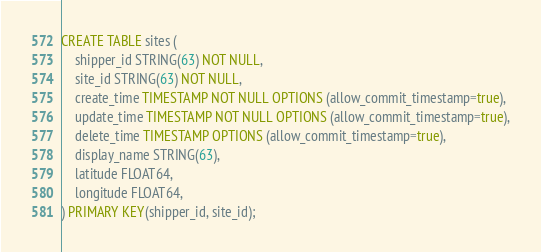Convert code to text. <code><loc_0><loc_0><loc_500><loc_500><_SQL_>CREATE TABLE sites (
    shipper_id STRING(63) NOT NULL,
    site_id STRING(63) NOT NULL,
    create_time TIMESTAMP NOT NULL OPTIONS (allow_commit_timestamp=true),
    update_time TIMESTAMP NOT NULL OPTIONS (allow_commit_timestamp=true),
    delete_time TIMESTAMP OPTIONS (allow_commit_timestamp=true),
    display_name STRING(63),
    latitude FLOAT64,
    longitude FLOAT64,
) PRIMARY KEY(shipper_id, site_id);
</code> 